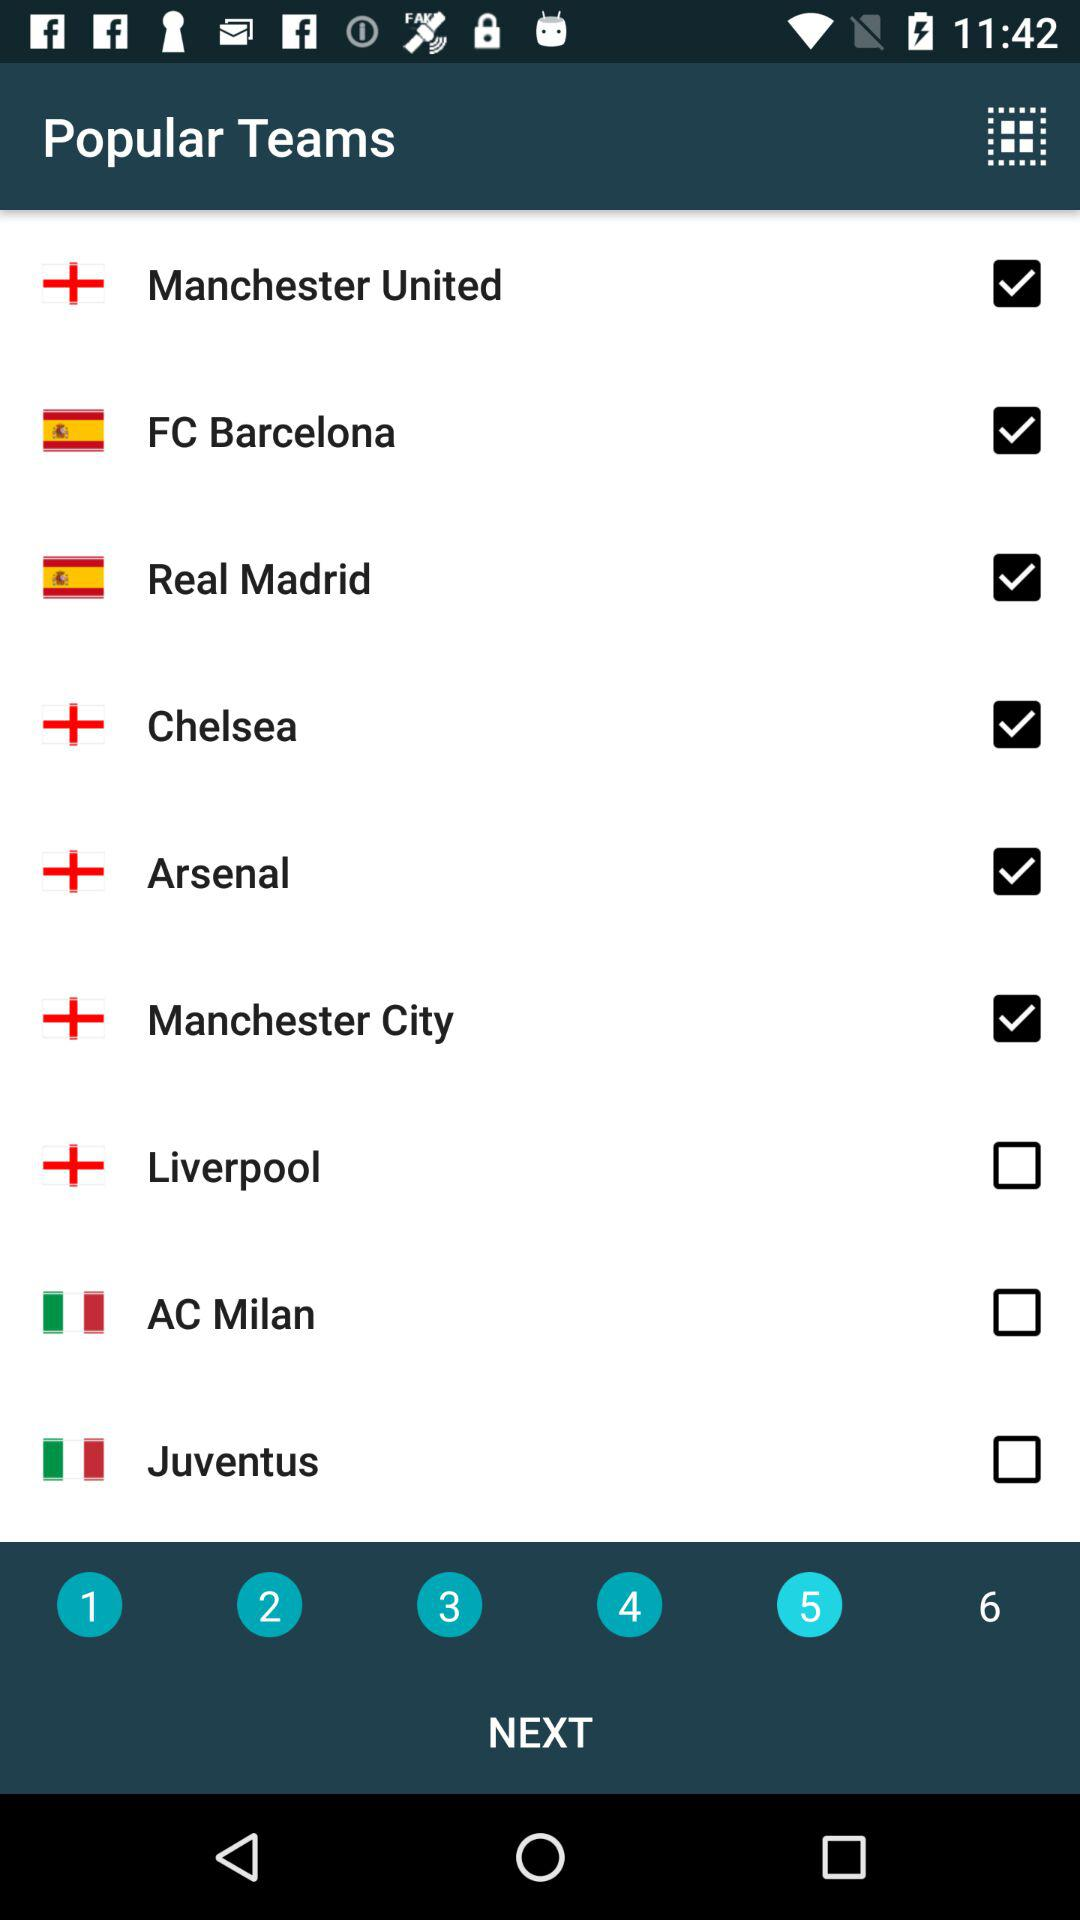How many teams have the country flag of Italy?
Answer the question using a single word or phrase. 2 